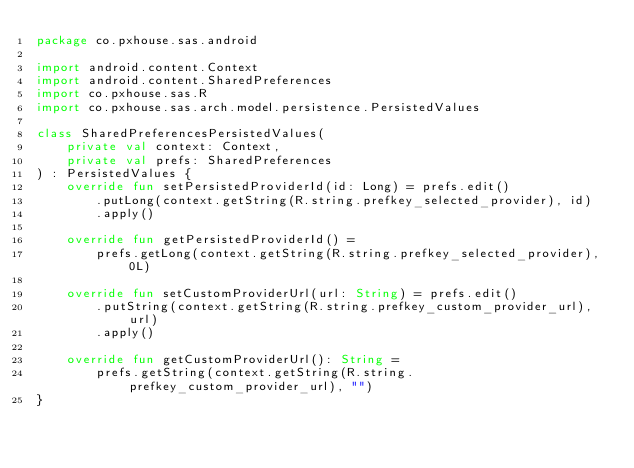<code> <loc_0><loc_0><loc_500><loc_500><_Kotlin_>package co.pxhouse.sas.android

import android.content.Context
import android.content.SharedPreferences
import co.pxhouse.sas.R
import co.pxhouse.sas.arch.model.persistence.PersistedValues

class SharedPreferencesPersistedValues(
    private val context: Context,
    private val prefs: SharedPreferences
) : PersistedValues {
    override fun setPersistedProviderId(id: Long) = prefs.edit()
        .putLong(context.getString(R.string.prefkey_selected_provider), id)
        .apply()

    override fun getPersistedProviderId() =
        prefs.getLong(context.getString(R.string.prefkey_selected_provider), 0L)

    override fun setCustomProviderUrl(url: String) = prefs.edit()
        .putString(context.getString(R.string.prefkey_custom_provider_url), url)
        .apply()

    override fun getCustomProviderUrl(): String =
        prefs.getString(context.getString(R.string.prefkey_custom_provider_url), "")
}</code> 